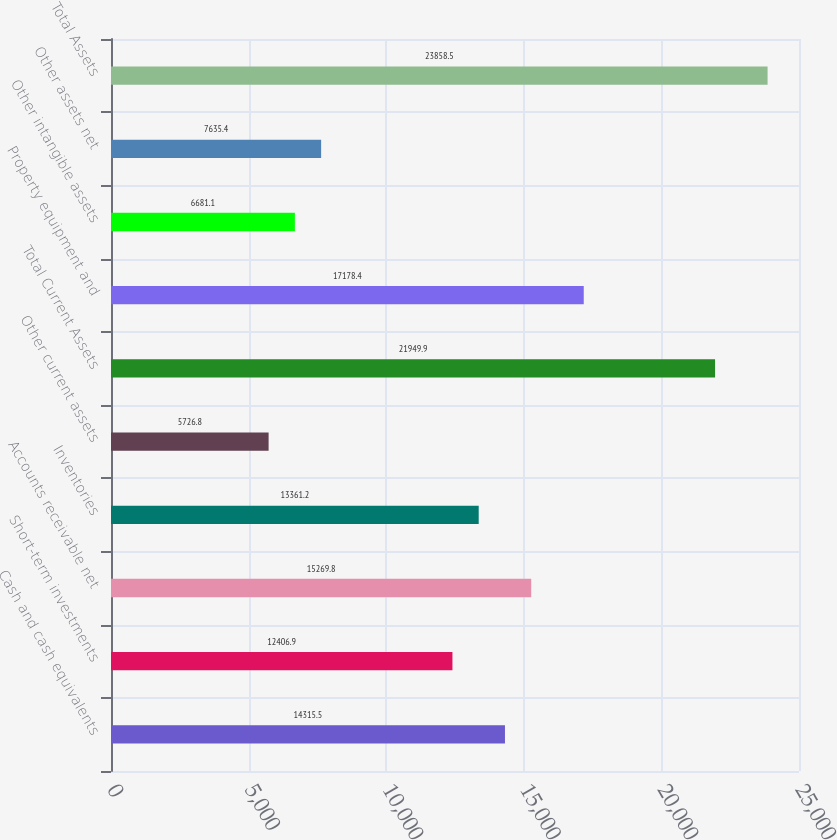Convert chart. <chart><loc_0><loc_0><loc_500><loc_500><bar_chart><fcel>Cash and cash equivalents<fcel>Short-term investments<fcel>Accounts receivable net<fcel>Inventories<fcel>Other current assets<fcel>Total Current Assets<fcel>Property equipment and<fcel>Other intangible assets<fcel>Other assets net<fcel>Total Assets<nl><fcel>14315.5<fcel>12406.9<fcel>15269.8<fcel>13361.2<fcel>5726.8<fcel>21949.9<fcel>17178.4<fcel>6681.1<fcel>7635.4<fcel>23858.5<nl></chart> 